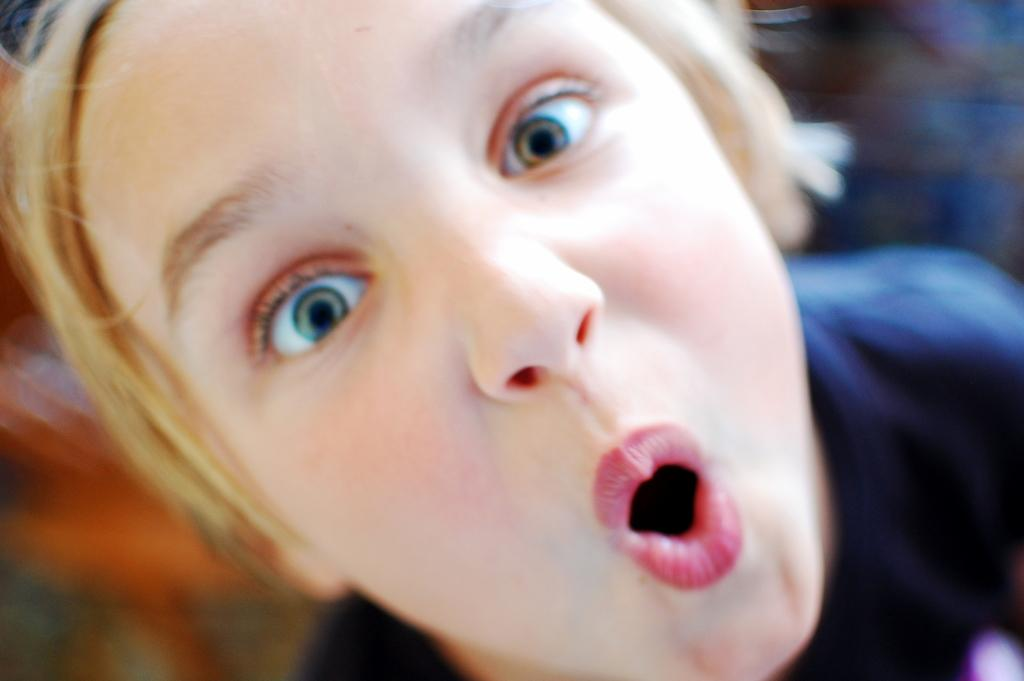Who or what is the main subject of the image? There is a person in the image. Can you describe the background of the image? The background of the image is blurred. What type of question is being asked in the image? There is no question present in the image; it features a person with a blurred background. Is the person wearing a sweater in the image? The provided facts do not mention the person's clothing, so it cannot be determined if they are wearing a sweater. 